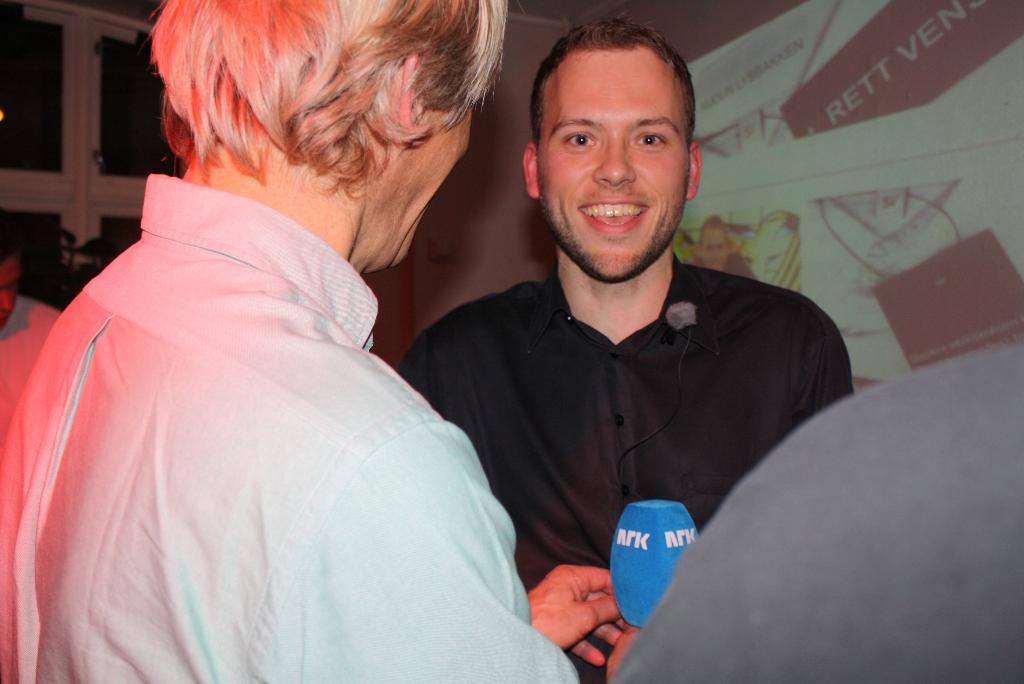What is the position of the first man in the image? There is a man on the left side of the image. What is the man on the left side wearing? The man on the left side is wearing a shirt. What is the position of the second man in the image? There is another man on the right side of the image. What is the expression of the second man in the image? The man on the right side is smiling. What color is the shirt worn by the second man in the image? The man on the right side is wearing a black color shirt. What type of shame can be seen on the geese in the image? There are no geese present in the image, so it is not possible to determine if they are experiencing any shame. 